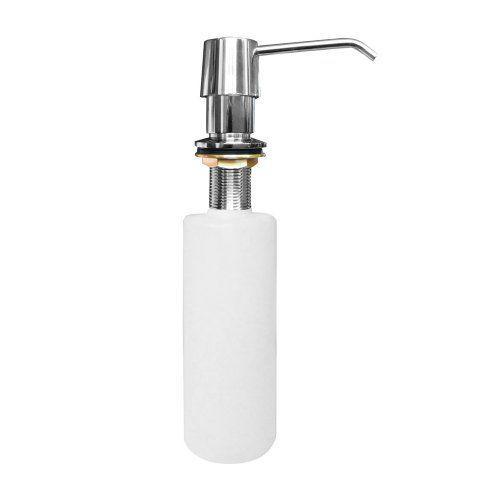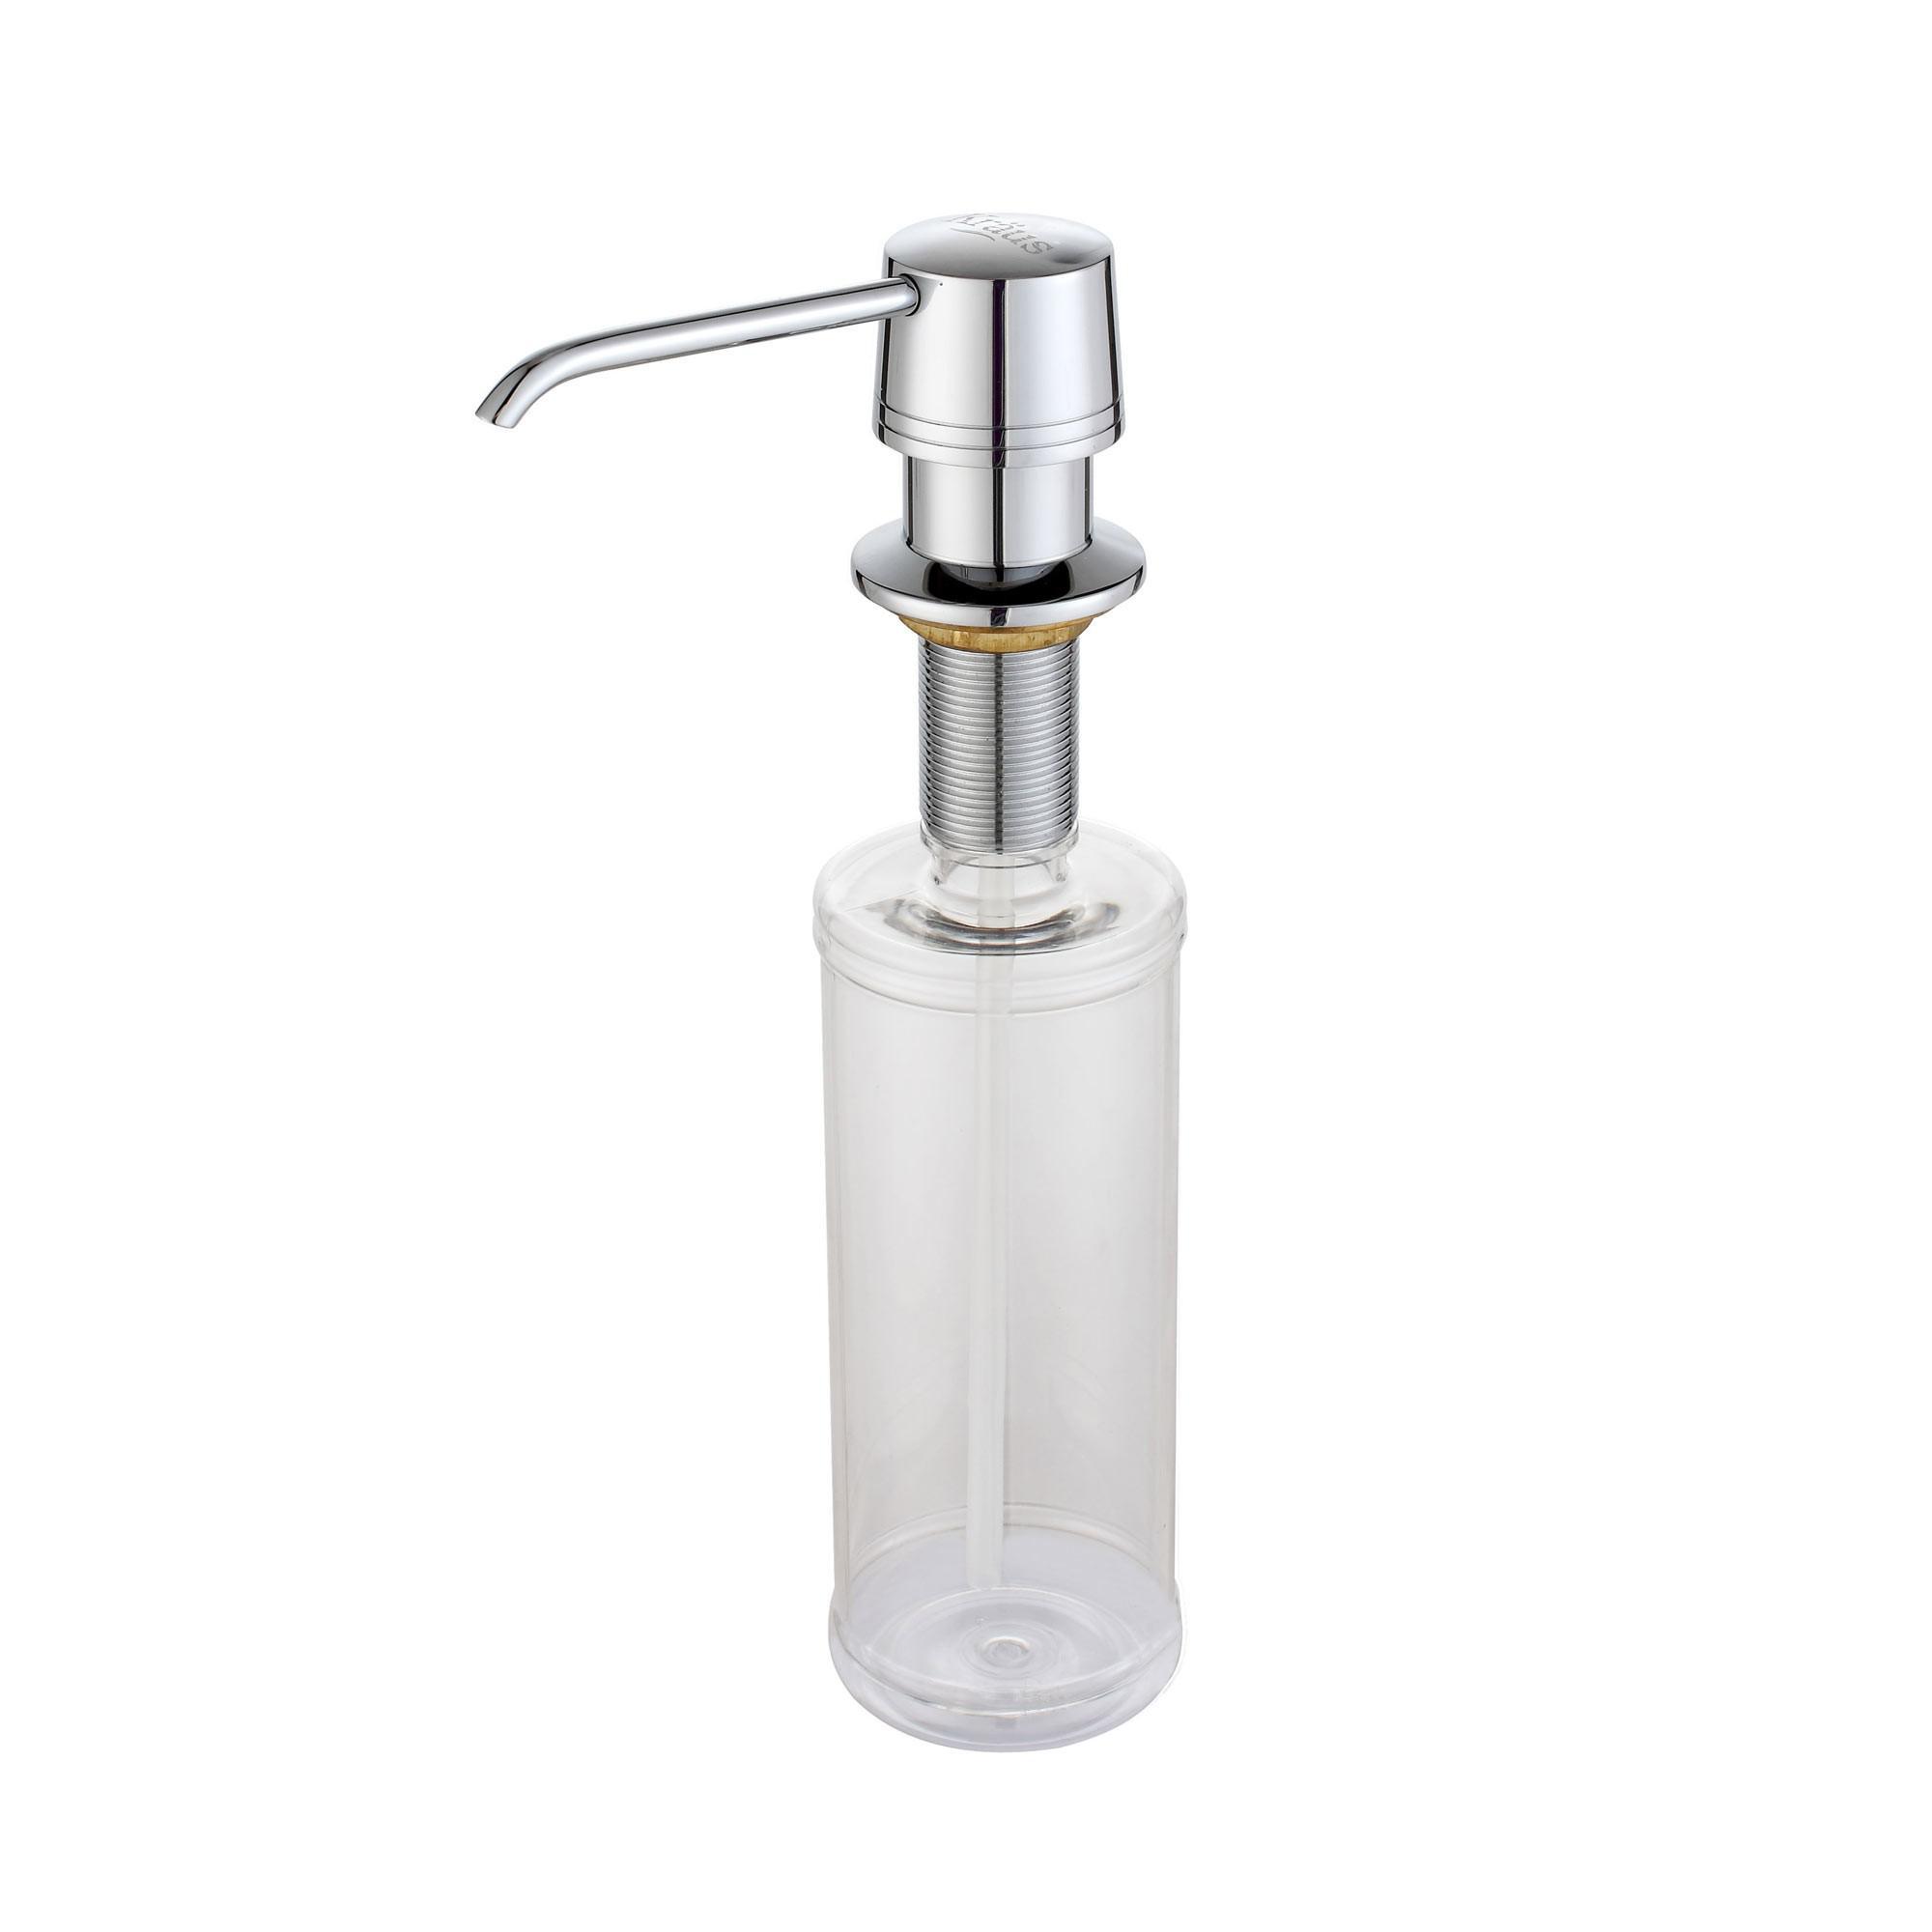The first image is the image on the left, the second image is the image on the right. Analyze the images presented: Is the assertion "The nozzles of the dispensers in the left and right images face generally toward each other." valid? Answer yes or no. Yes. The first image is the image on the left, the second image is the image on the right. For the images shown, is this caption "The dispenser in the right photo has a transparent bottle." true? Answer yes or no. Yes. 